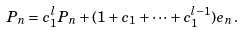Convert formula to latex. <formula><loc_0><loc_0><loc_500><loc_500>P _ { n } = c _ { 1 } ^ { l } P _ { n } + ( 1 + c _ { 1 } + \dots + c _ { 1 } ^ { l - 1 } ) e _ { n } .</formula> 